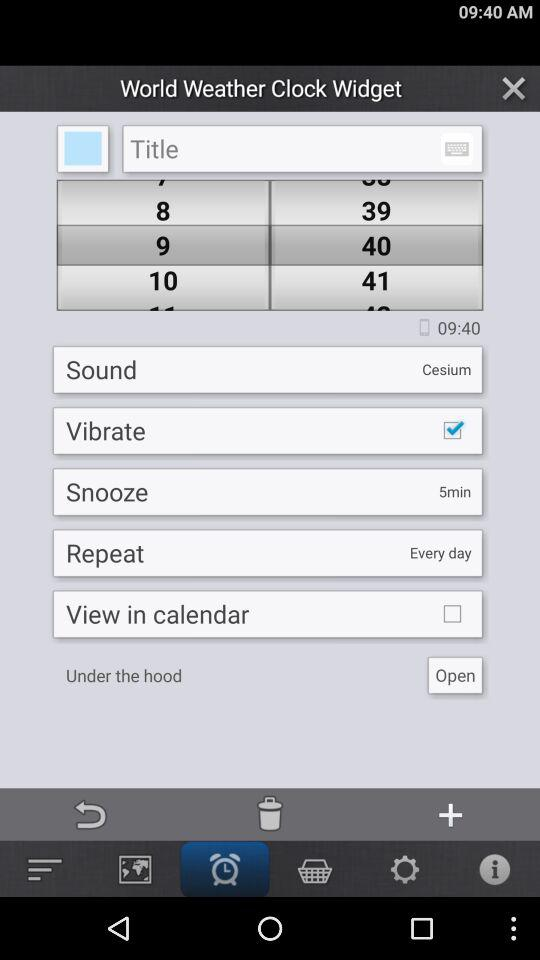How often will it repeat? It will repeat every day. 